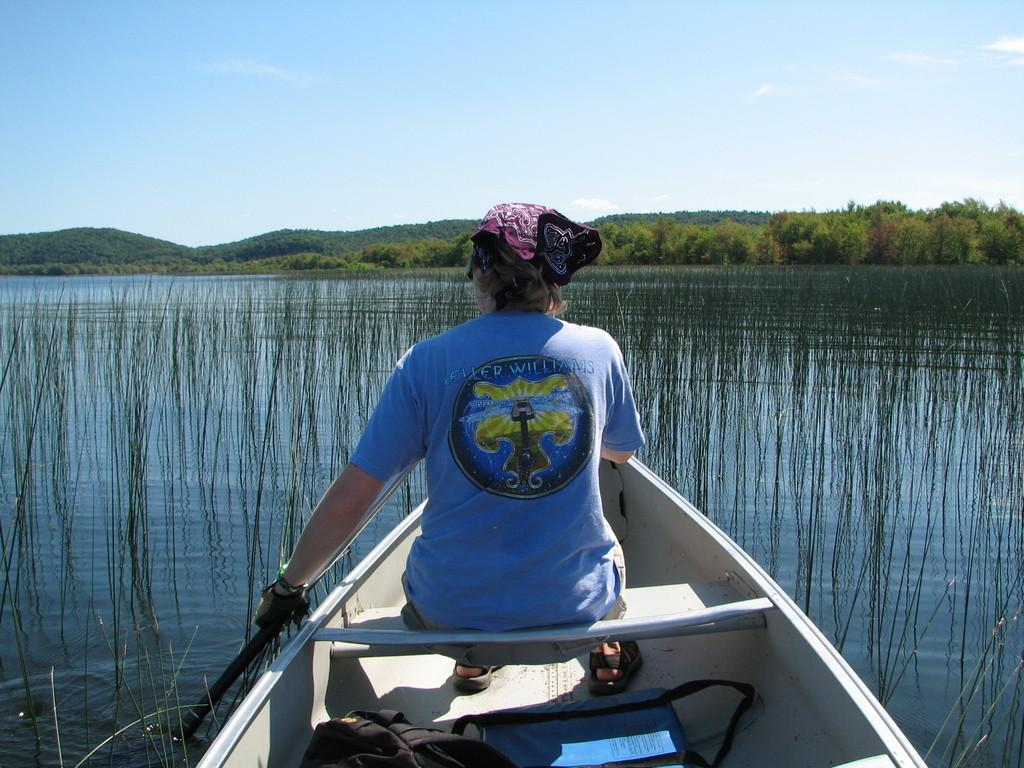Who is present in the image? There is a woman in the image. What is the woman doing in the image? The woman is sitting on a boat. Where is the boat located in the image? The boat is sailing on a river. What can be seen in the background of the image? There are trees, mountains, and the sky visible in the background of the image. What type of boot is the woman wearing in the image? There is no mention of the woman wearing boots in the image; she is sitting on a boat. 